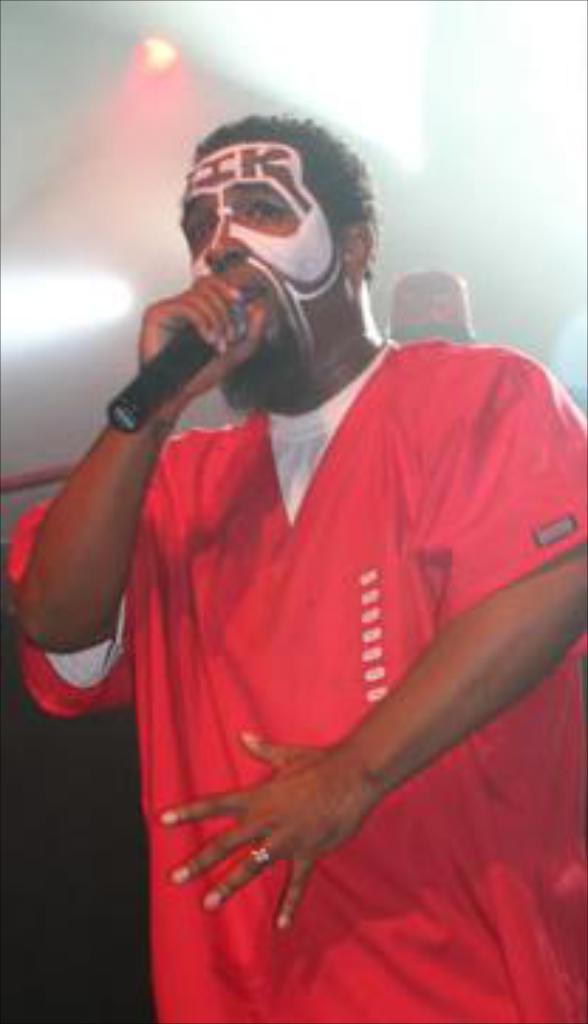What is the person in the image doing? The person is standing in the image and holding a microphone. What color is the dress the person is wearing? The person is wearing a red dress. What can be seen at the top of the image? There are lights visible at the top of the image. What type of cord is attached to the microphone in the image? There is no visible cord attached to the microphone in the image. How does the person's performance compare to other competitors in the image? There is no competition or other performers present in the image, so it cannot be determined how the person's performance compares to others. 